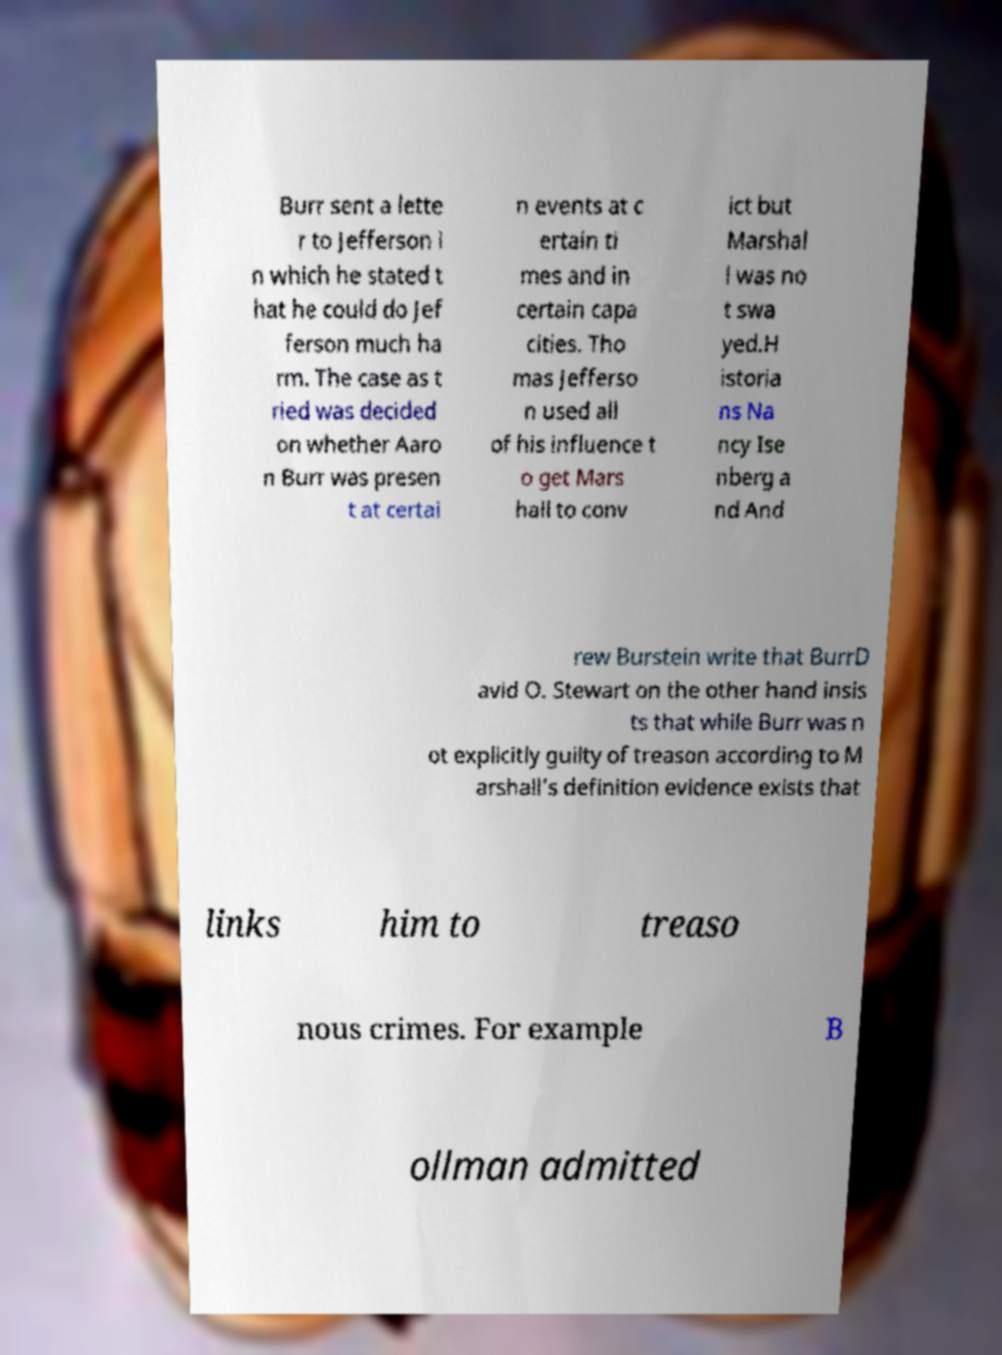Please identify and transcribe the text found in this image. Burr sent a lette r to Jefferson i n which he stated t hat he could do Jef ferson much ha rm. The case as t ried was decided on whether Aaro n Burr was presen t at certai n events at c ertain ti mes and in certain capa cities. Tho mas Jefferso n used all of his influence t o get Mars hall to conv ict but Marshal l was no t swa yed.H istoria ns Na ncy Ise nberg a nd And rew Burstein write that BurrD avid O. Stewart on the other hand insis ts that while Burr was n ot explicitly guilty of treason according to M arshall's definition evidence exists that links him to treaso nous crimes. For example B ollman admitted 